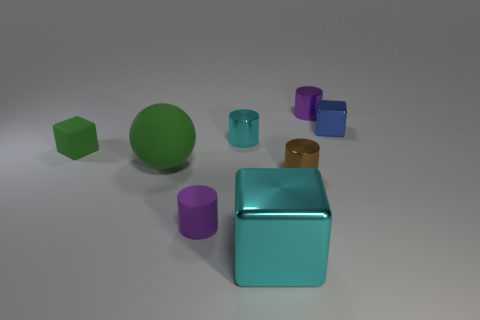What number of cylinders are tiny brown objects or purple things?
Offer a terse response. 3. There is a big thing that is the same material as the small blue object; what color is it?
Your answer should be compact. Cyan. Is the material of the sphere the same as the purple thing in front of the small green object?
Your response must be concise. Yes. What number of things are either brown metal cylinders or green things?
Your answer should be compact. 3. There is a thing that is the same color as the big matte ball; what is its material?
Offer a terse response. Rubber. Is there a purple matte thing that has the same shape as the tiny cyan metal thing?
Your answer should be very brief. Yes. How many metal things are in front of the small blue metal cube?
Keep it short and to the point. 3. What material is the tiny cube on the right side of the purple thing that is behind the tiny brown metallic cylinder made of?
Offer a very short reply. Metal. There is a brown cylinder that is the same size as the blue object; what material is it?
Your response must be concise. Metal. Are there any purple metallic cylinders of the same size as the green rubber block?
Provide a succinct answer. Yes. 